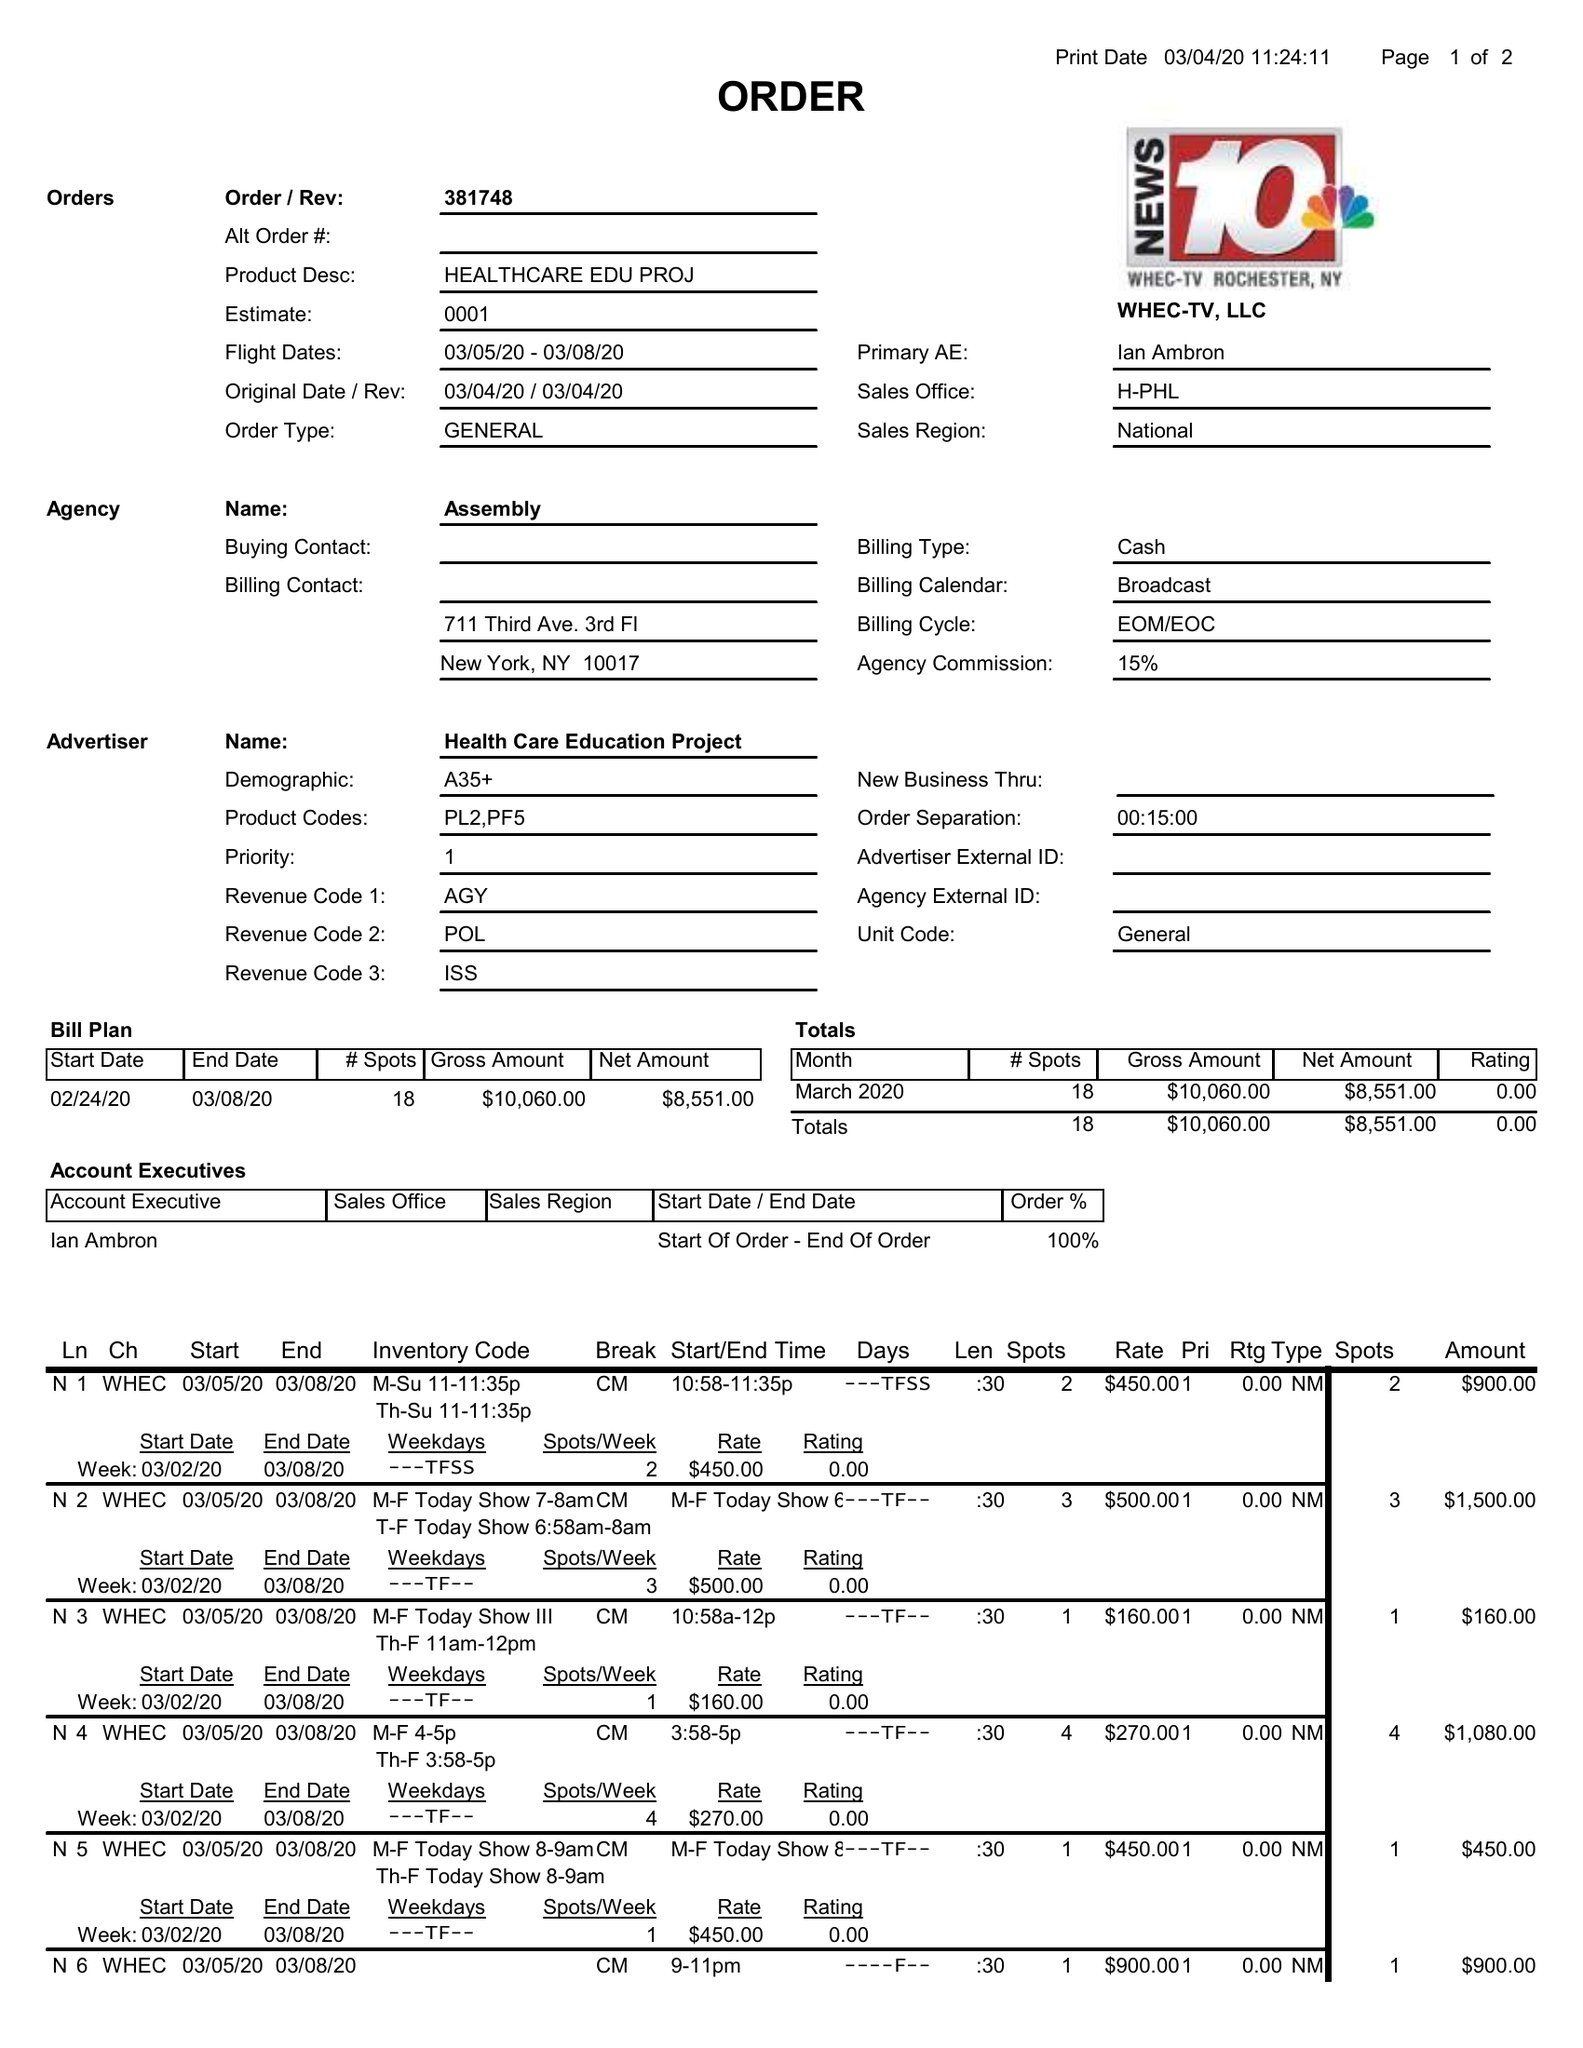What is the value for the flight_from?
Answer the question using a single word or phrase. 03/05/20 